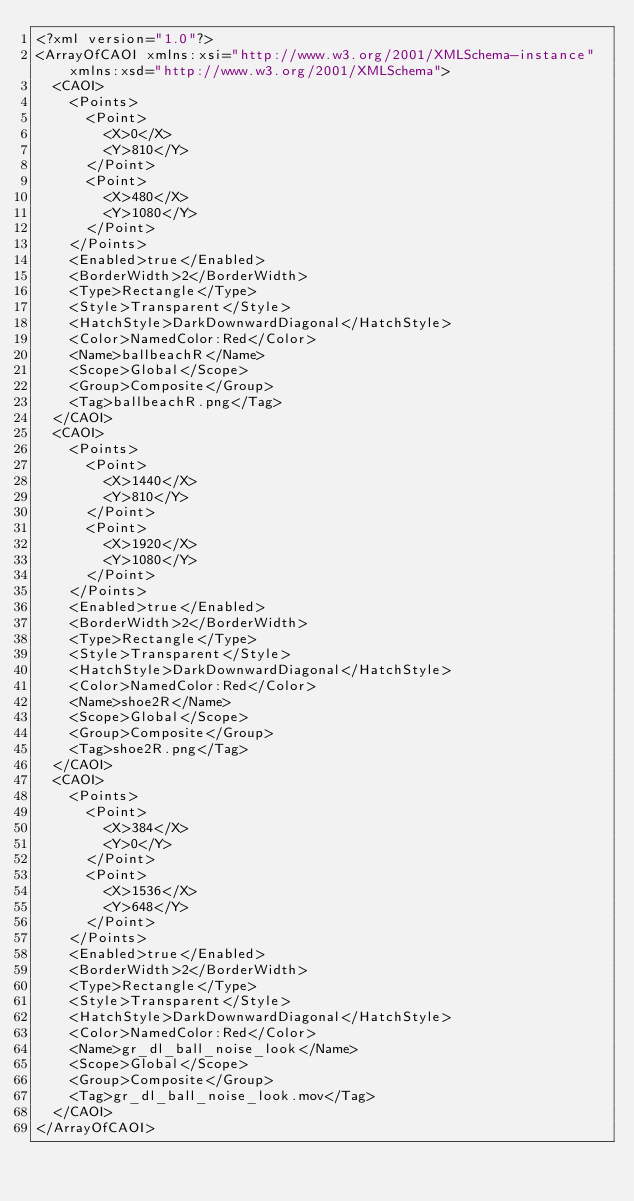Convert code to text. <code><loc_0><loc_0><loc_500><loc_500><_XML_><?xml version="1.0"?>
<ArrayOfCAOI xmlns:xsi="http://www.w3.org/2001/XMLSchema-instance" xmlns:xsd="http://www.w3.org/2001/XMLSchema">
  <CAOI>
    <Points>
      <Point>
        <X>0</X>
        <Y>810</Y>
      </Point>
      <Point>
        <X>480</X>
        <Y>1080</Y>
      </Point>
    </Points>
    <Enabled>true</Enabled>
    <BorderWidth>2</BorderWidth>
    <Type>Rectangle</Type>
    <Style>Transparent</Style>
    <HatchStyle>DarkDownwardDiagonal</HatchStyle>
    <Color>NamedColor:Red</Color>
    <Name>ballbeachR</Name>
    <Scope>Global</Scope>
    <Group>Composite</Group>
    <Tag>ballbeachR.png</Tag>
  </CAOI>
  <CAOI>
    <Points>
      <Point>
        <X>1440</X>
        <Y>810</Y>
      </Point>
      <Point>
        <X>1920</X>
        <Y>1080</Y>
      </Point>
    </Points>
    <Enabled>true</Enabled>
    <BorderWidth>2</BorderWidth>
    <Type>Rectangle</Type>
    <Style>Transparent</Style>
    <HatchStyle>DarkDownwardDiagonal</HatchStyle>
    <Color>NamedColor:Red</Color>
    <Name>shoe2R</Name>
    <Scope>Global</Scope>
    <Group>Composite</Group>
    <Tag>shoe2R.png</Tag>
  </CAOI>
  <CAOI>
    <Points>
      <Point>
        <X>384</X>
        <Y>0</Y>
      </Point>
      <Point>
        <X>1536</X>
        <Y>648</Y>
      </Point>
    </Points>
    <Enabled>true</Enabled>
    <BorderWidth>2</BorderWidth>
    <Type>Rectangle</Type>
    <Style>Transparent</Style>
    <HatchStyle>DarkDownwardDiagonal</HatchStyle>
    <Color>NamedColor:Red</Color>
    <Name>gr_dl_ball_noise_look</Name>
    <Scope>Global</Scope>
    <Group>Composite</Group>
    <Tag>gr_dl_ball_noise_look.mov</Tag>
  </CAOI>
</ArrayOfCAOI></code> 